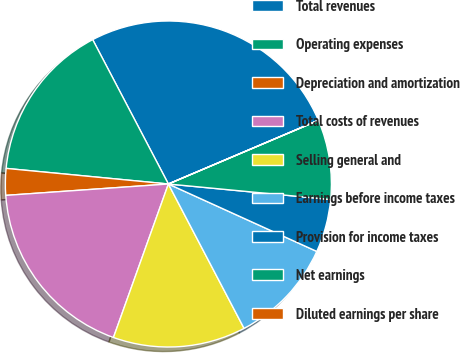Convert chart to OTSL. <chart><loc_0><loc_0><loc_500><loc_500><pie_chart><fcel>Total revenues<fcel>Operating expenses<fcel>Depreciation and amortization<fcel>Total costs of revenues<fcel>Selling general and<fcel>Earnings before income taxes<fcel>Provision for income taxes<fcel>Net earnings<fcel>Diluted earnings per share<nl><fcel>26.3%<fcel>15.79%<fcel>2.64%<fcel>18.42%<fcel>13.16%<fcel>10.53%<fcel>5.27%<fcel>7.9%<fcel>0.01%<nl></chart> 